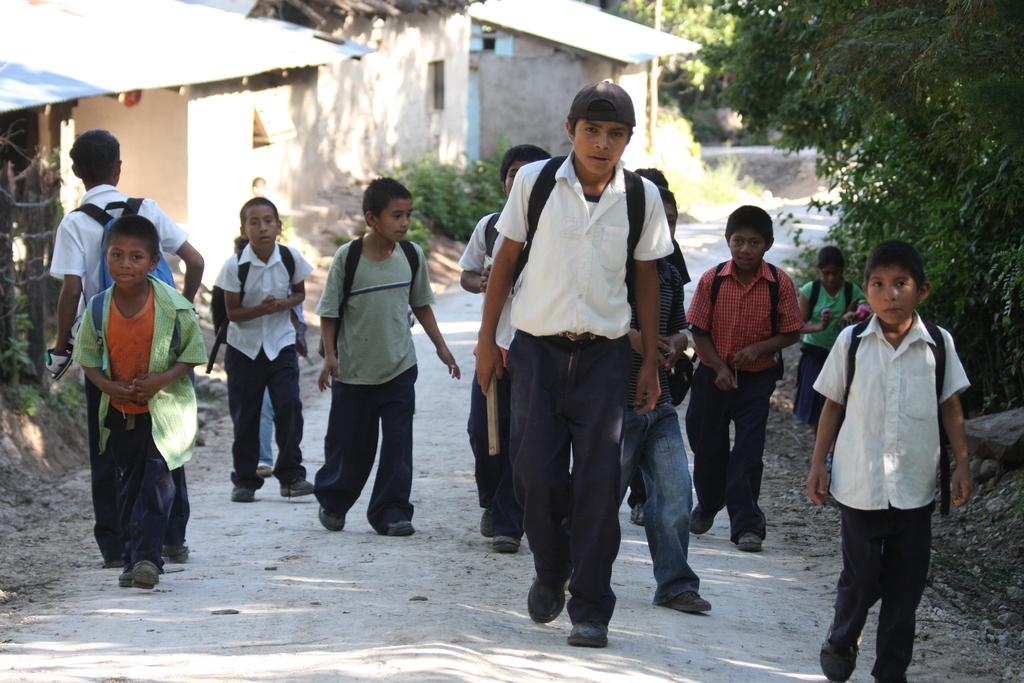What is the main subject of the image? The main subject of the image is a group of people. What are the people wearing in the image? The people are wearing bags in the image. What can be seen in the background of the image? There are houses and trees in the background of the image. What type of farm animals can be seen in the image? There are no farm animals present in the image. How much milk is being produced by the cows in the image? There are no cows or milk production in the image. 